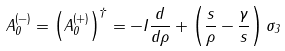Convert formula to latex. <formula><loc_0><loc_0><loc_500><loc_500>A ^ { ( - ) } _ { 0 } = \left ( A _ { 0 } ^ { ( + ) } \right ) ^ { \dagger } = - { I } \frac { d } { d \rho } + \left ( \frac { s } { \rho } - \frac { \gamma } { s } \right ) \sigma _ { 3 }</formula> 